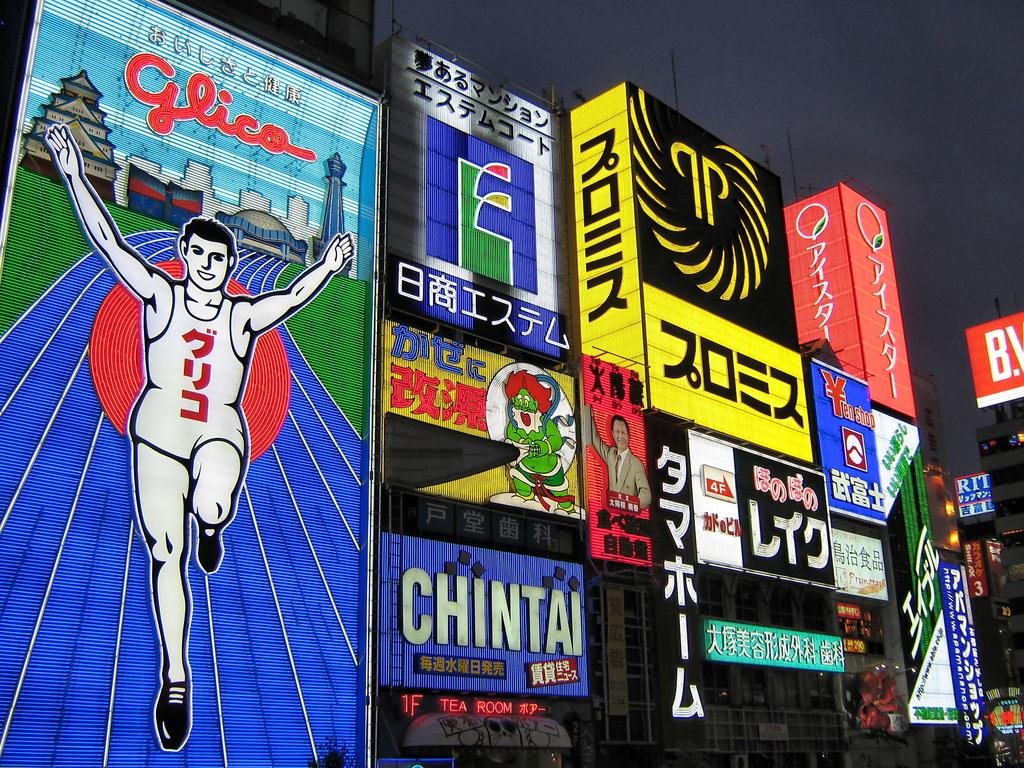What brand is above the runner?
Your answer should be very brief. Glica. What is the brand being advertised in blue at the bottom?
Provide a succinct answer. Chintai. 